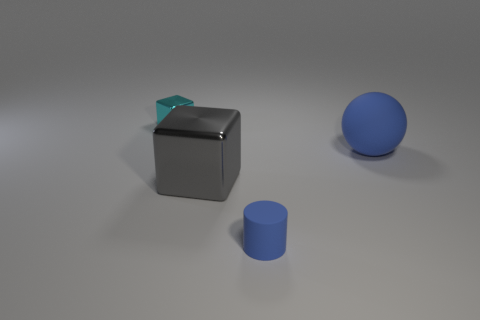The small blue object has what shape? The small blue object in the image is a cylinder with a circular base and a smooth, curved surface extending upwards. 